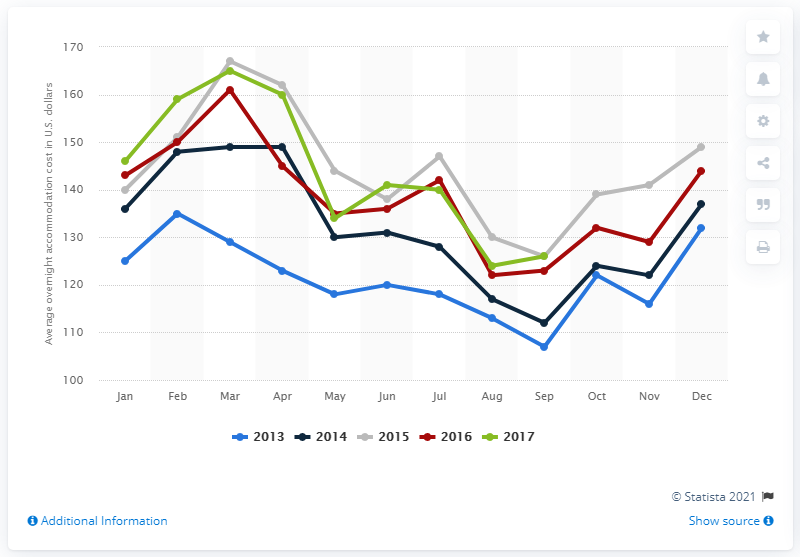Give some essential details in this illustration. In July 2017, the average cost of overnight accommodation in Orlando was approximately 140 USD. 